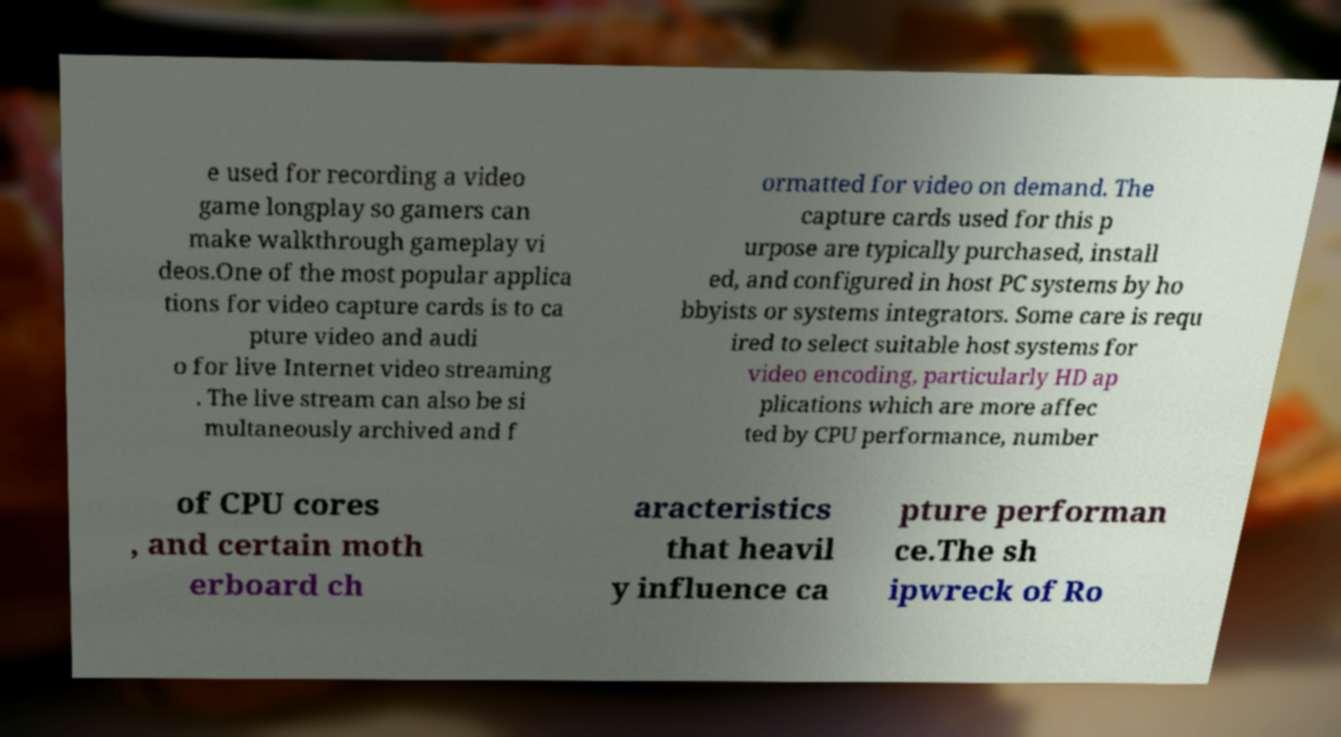Can you accurately transcribe the text from the provided image for me? e used for recording a video game longplay so gamers can make walkthrough gameplay vi deos.One of the most popular applica tions for video capture cards is to ca pture video and audi o for live Internet video streaming . The live stream can also be si multaneously archived and f ormatted for video on demand. The capture cards used for this p urpose are typically purchased, install ed, and configured in host PC systems by ho bbyists or systems integrators. Some care is requ ired to select suitable host systems for video encoding, particularly HD ap plications which are more affec ted by CPU performance, number of CPU cores , and certain moth erboard ch aracteristics that heavil y influence ca pture performan ce.The sh ipwreck of Ro 